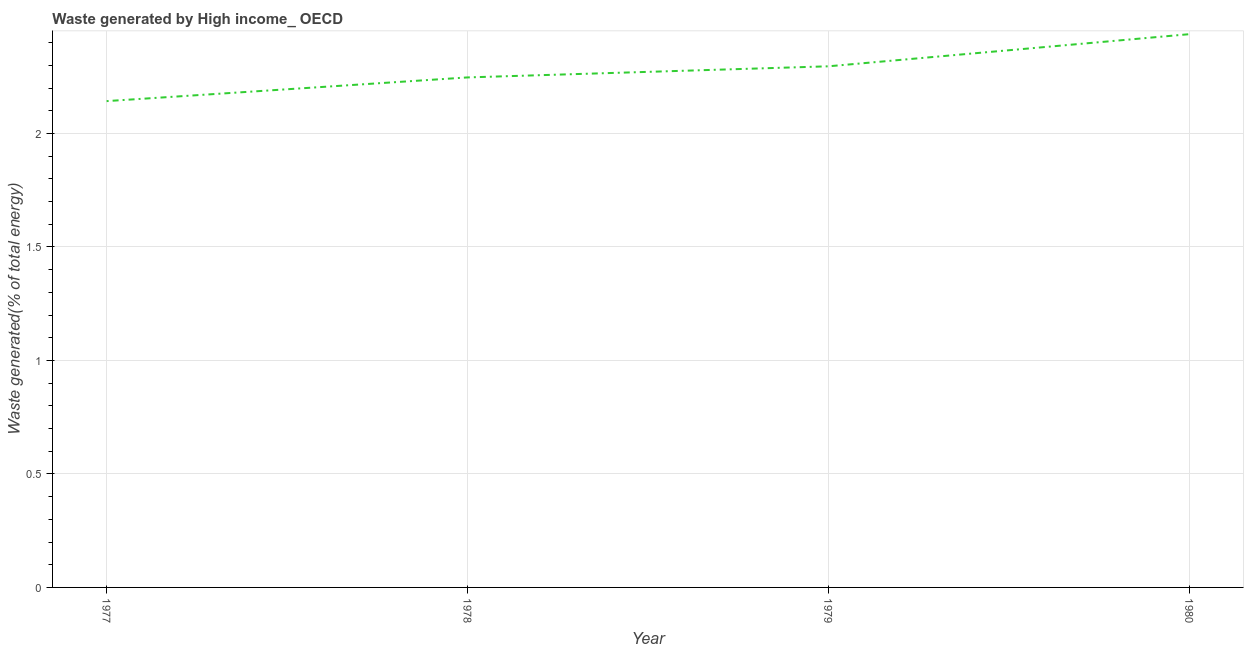What is the amount of waste generated in 1980?
Your response must be concise. 2.44. Across all years, what is the maximum amount of waste generated?
Provide a short and direct response. 2.44. Across all years, what is the minimum amount of waste generated?
Give a very brief answer. 2.14. In which year was the amount of waste generated maximum?
Give a very brief answer. 1980. In which year was the amount of waste generated minimum?
Provide a short and direct response. 1977. What is the sum of the amount of waste generated?
Give a very brief answer. 9.12. What is the difference between the amount of waste generated in 1977 and 1979?
Provide a short and direct response. -0.15. What is the average amount of waste generated per year?
Provide a short and direct response. 2.28. What is the median amount of waste generated?
Give a very brief answer. 2.27. What is the ratio of the amount of waste generated in 1978 to that in 1980?
Your response must be concise. 0.92. What is the difference between the highest and the second highest amount of waste generated?
Your answer should be very brief. 0.14. Is the sum of the amount of waste generated in 1979 and 1980 greater than the maximum amount of waste generated across all years?
Your response must be concise. Yes. What is the difference between the highest and the lowest amount of waste generated?
Offer a very short reply. 0.29. In how many years, is the amount of waste generated greater than the average amount of waste generated taken over all years?
Your answer should be very brief. 2. How many years are there in the graph?
Your answer should be compact. 4. What is the difference between two consecutive major ticks on the Y-axis?
Your answer should be compact. 0.5. Does the graph contain any zero values?
Your response must be concise. No. Does the graph contain grids?
Give a very brief answer. Yes. What is the title of the graph?
Your answer should be compact. Waste generated by High income_ OECD. What is the label or title of the X-axis?
Your answer should be compact. Year. What is the label or title of the Y-axis?
Your response must be concise. Waste generated(% of total energy). What is the Waste generated(% of total energy) in 1977?
Provide a succinct answer. 2.14. What is the Waste generated(% of total energy) of 1978?
Keep it short and to the point. 2.25. What is the Waste generated(% of total energy) of 1979?
Provide a short and direct response. 2.3. What is the Waste generated(% of total energy) of 1980?
Keep it short and to the point. 2.44. What is the difference between the Waste generated(% of total energy) in 1977 and 1978?
Your answer should be very brief. -0.1. What is the difference between the Waste generated(% of total energy) in 1977 and 1979?
Make the answer very short. -0.15. What is the difference between the Waste generated(% of total energy) in 1977 and 1980?
Your response must be concise. -0.29. What is the difference between the Waste generated(% of total energy) in 1978 and 1979?
Provide a short and direct response. -0.05. What is the difference between the Waste generated(% of total energy) in 1978 and 1980?
Give a very brief answer. -0.19. What is the difference between the Waste generated(% of total energy) in 1979 and 1980?
Provide a succinct answer. -0.14. What is the ratio of the Waste generated(% of total energy) in 1977 to that in 1978?
Ensure brevity in your answer.  0.95. What is the ratio of the Waste generated(% of total energy) in 1977 to that in 1979?
Offer a terse response. 0.93. What is the ratio of the Waste generated(% of total energy) in 1977 to that in 1980?
Offer a very short reply. 0.88. What is the ratio of the Waste generated(% of total energy) in 1978 to that in 1979?
Provide a short and direct response. 0.98. What is the ratio of the Waste generated(% of total energy) in 1978 to that in 1980?
Ensure brevity in your answer.  0.92. What is the ratio of the Waste generated(% of total energy) in 1979 to that in 1980?
Provide a short and direct response. 0.94. 